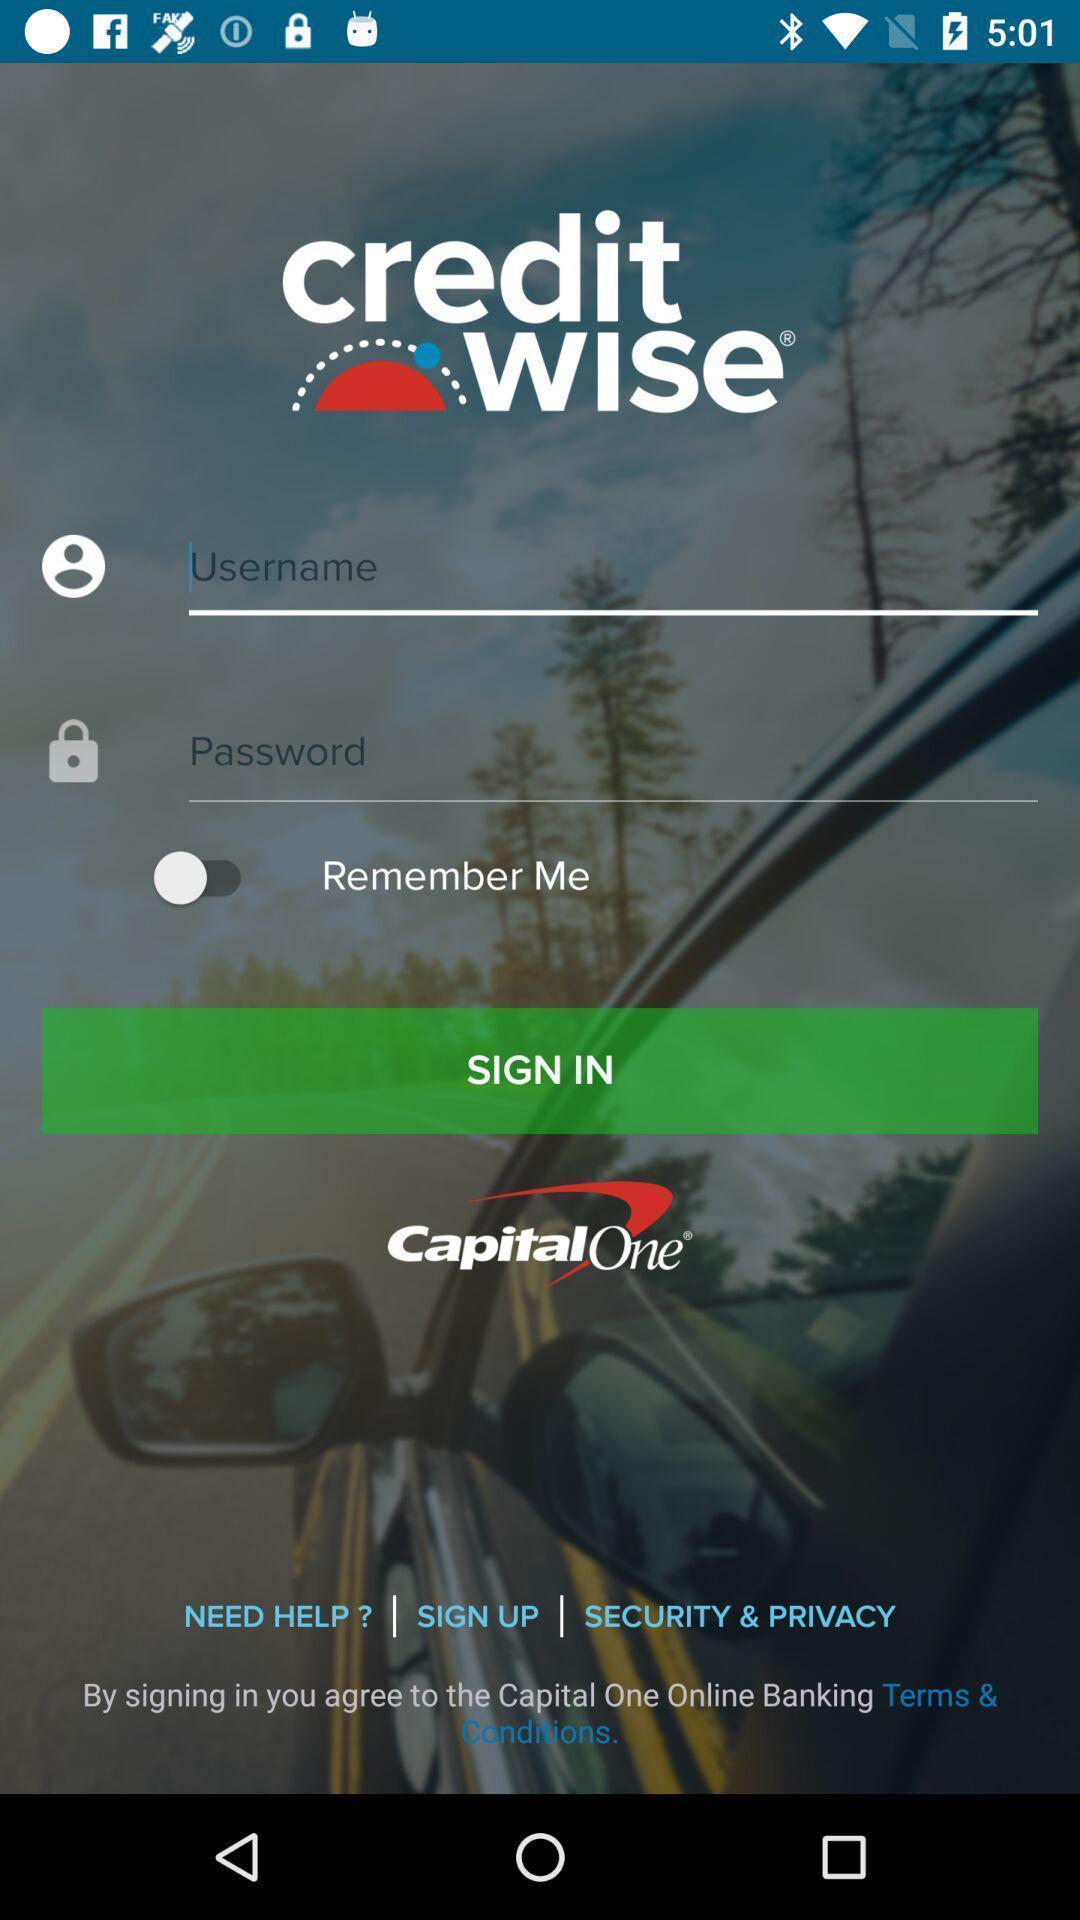Provide a textual representation of this image. Sign up page for credit score app. 